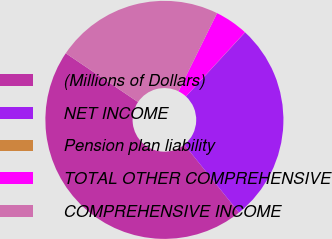Convert chart to OTSL. <chart><loc_0><loc_0><loc_500><loc_500><pie_chart><fcel>(Millions of Dollars)<fcel>NET INCOME<fcel>Pension plan liability<fcel>TOTAL OTHER COMPREHENSIVE<fcel>COMPREHENSIVE INCOME<nl><fcel>45.23%<fcel>27.36%<fcel>0.02%<fcel>4.54%<fcel>22.84%<nl></chart> 